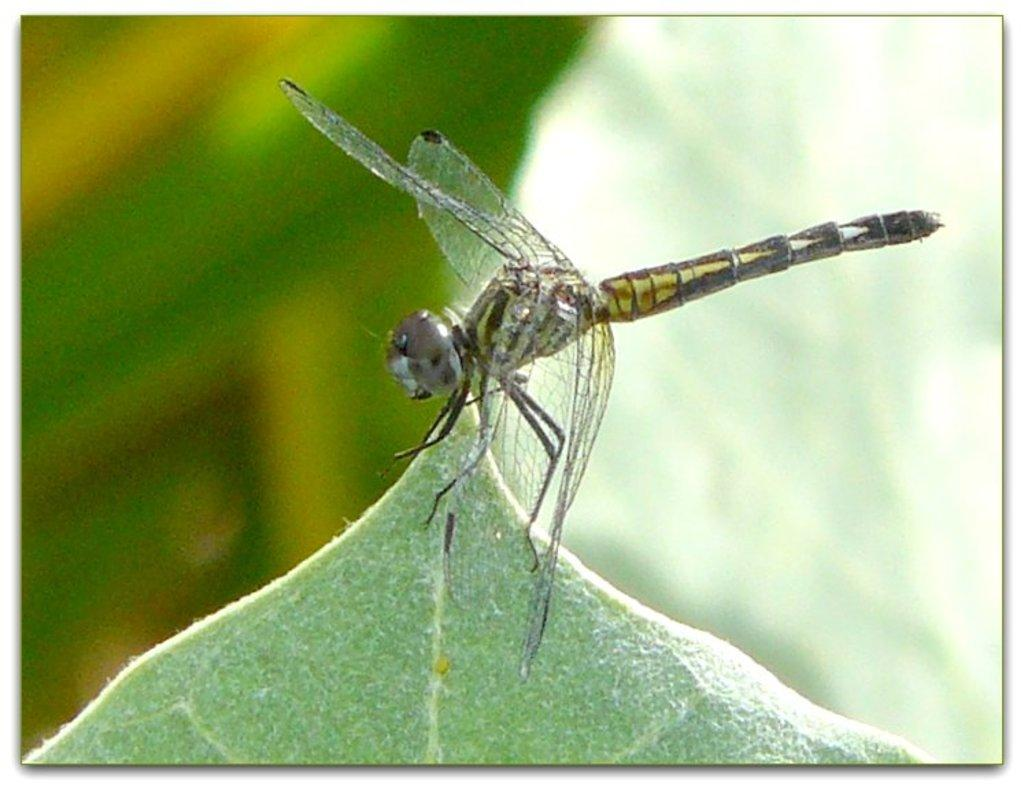What is present in the image? There is an insect in the image. Where is the insect located? The insect is on a leaf. Can you describe the background of the image? The background of the image is blurred. What type of yak can be seen in the image? There is no yak present in the image; it features an insect on a leaf. What kind of laborer is working in the background of the image? There is no laborer present in the image; the background is blurred. 